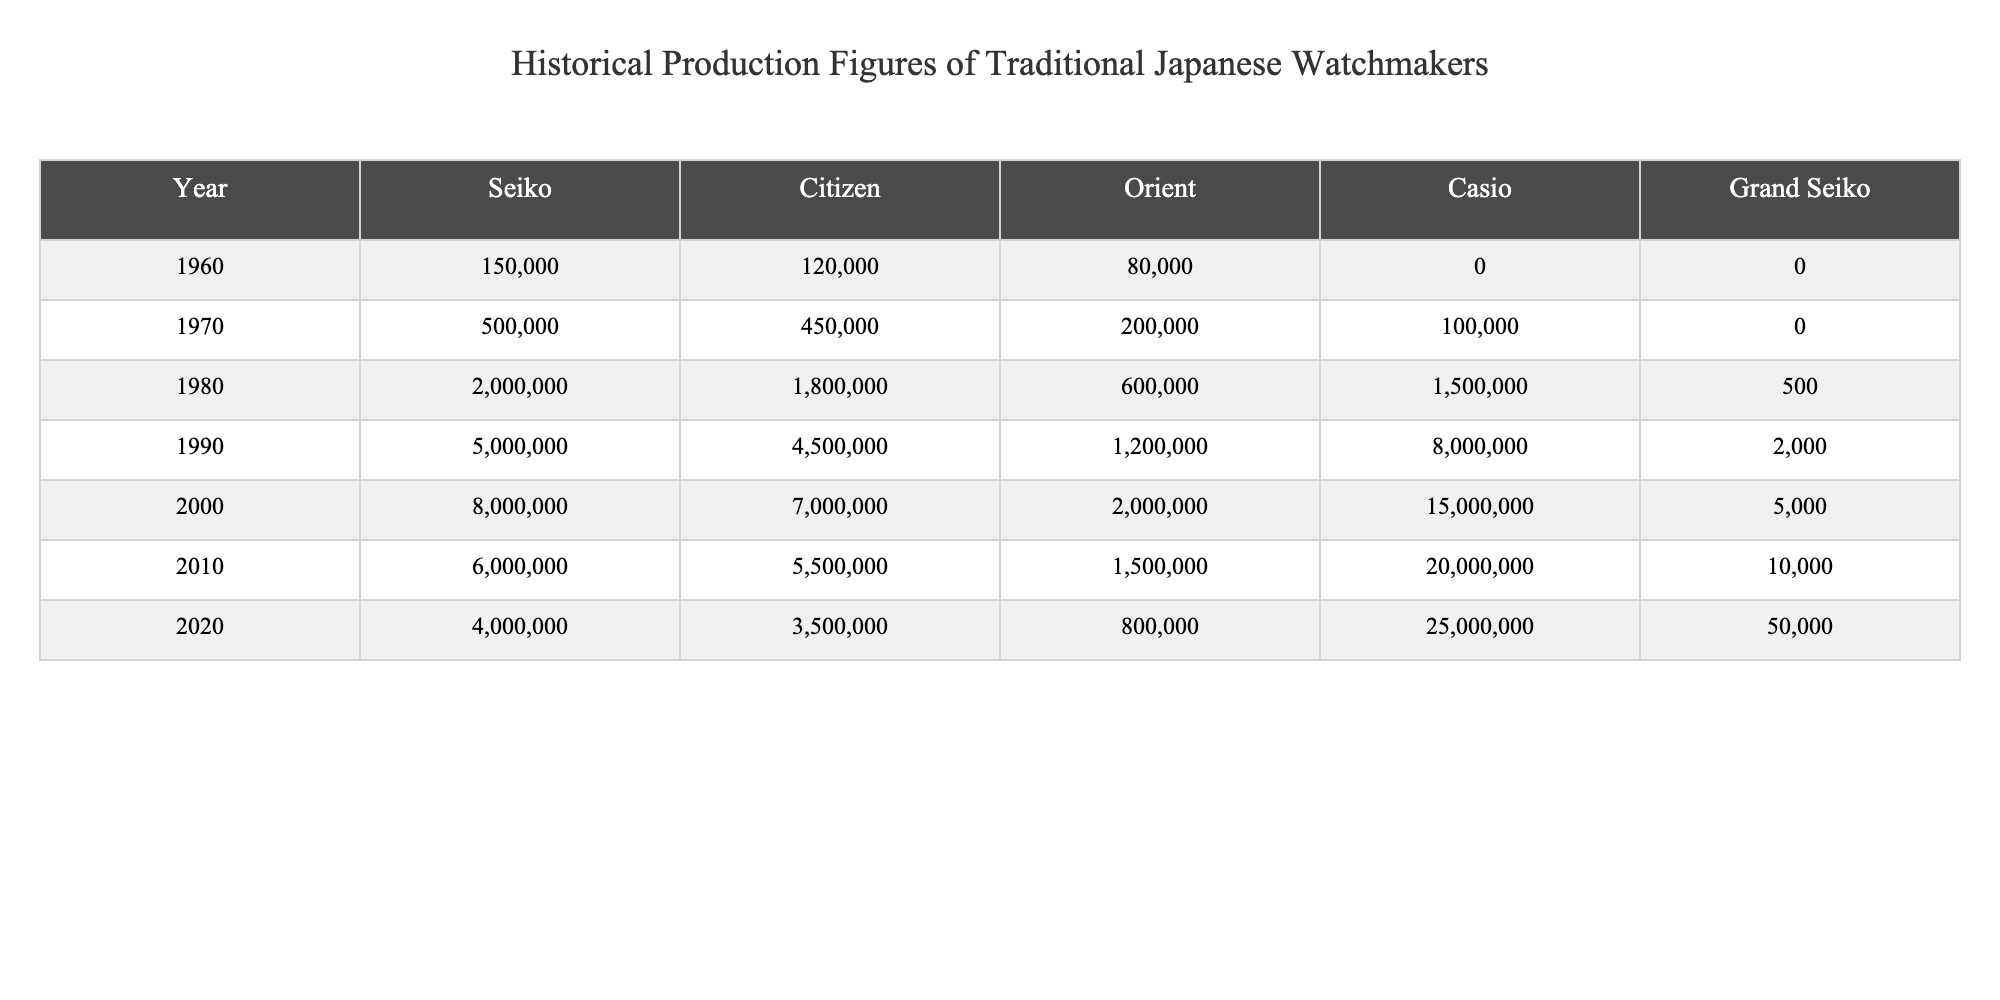What was the production figure for Seiko in 1990? The table shows that in 1990, Seiko produced 5,000,000 units.
Answer: 5,000,000 Which watchmaker had the lowest production in 1980? In 1980, the lowest production was by Grand Seiko with 500 units.
Answer: Grand Seiko What is the total production of Citizen from 1960 to 2020? Adding the production figures for Citizen over these years: 120,000 + 450,000 + 1,800,000 + 4,500,000 + 7,000,000 + 5,500,000 + 3,500,000 gives a total of 22,870,000 units.
Answer: 22,870,000 Did Casio produce more than 10 million units in any year? In 2000 and 2010, Casio produced 15,000,000 and 20,000,000 units respectively, which are both more than 10 million.
Answer: Yes What was the increase in Grand Seiko production from 2000 to 2020? Grand Seiko produced 5,000 units in 2000 and 50,000 units in 2020. The increase is calculated as 50,000 - 5,000 = 45,000 units.
Answer: 45,000 Which year had the highest total production among all watchmakers? In 2010, the total production was 60,000,000 (6,000,000 + 5,500,000 + 1,500,000 + 20,000,000 + 10,000). This is the highest across all years.
Answer: 2010 How much more did Casio produce than Orient in 2000? In 2000, Casio produced 15,000,000 and Orient produced 2,000,000. The difference is 15,000,000 - 2,000,000 = 13,000,000 units.
Answer: 13,000,000 Was there a year when the production of Seiko was lower than Orient? In 1960, Seiko produced 150,000 while Orient produced 80,000. Therefore, Seiko produced more than Orient in that year. So, the answer is no.
Answer: No What was the average production of Casio over the years provided? Summing Casio's production figures: 0 + 100,000 + 1,500,000 + 8,000,000 + 15,000,000 + 20,000,000 + 25,000,000 gives 69,600,000. Dividing this by 7 gives an average of 9,942,857 (approximately).
Answer: 9,942,857 Which watchmaker's production experienced the steepest increase from 2000 to 2010? Comparing the production figures: Seiko (8,000,000 to 6,000,000, a decrease), Citizen (7,000,000 to 5,500,000, a decrease), Orient (2,000,000 to 1,500,000, a decrease), Casio (15,000,000 to 20,000,000, an increase of 5,000,000), and Grand Seiko (5,000 to 10,000, an increase of 5,000), it is clear that Casio had the steepest increase.
Answer: Casio 